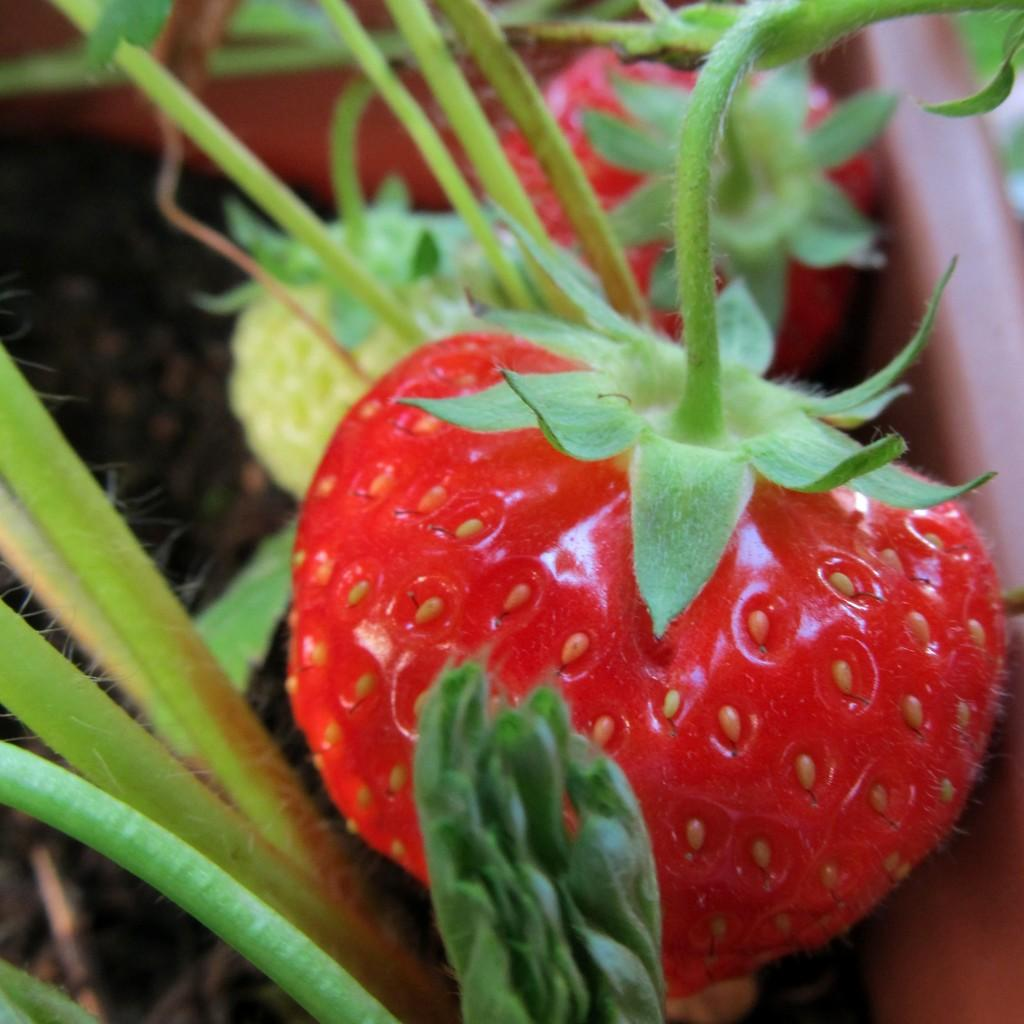What type of fruit is in the image? There is a strawberry fruit in the image. What else can be seen in the image besides the fruit? There are leaves visible in the image. What type of fang can be seen in the image? There is no fang present in the image; it features a strawberry fruit and leaves. What type of pencil is visible in the image? There is no pencil present in the image. 